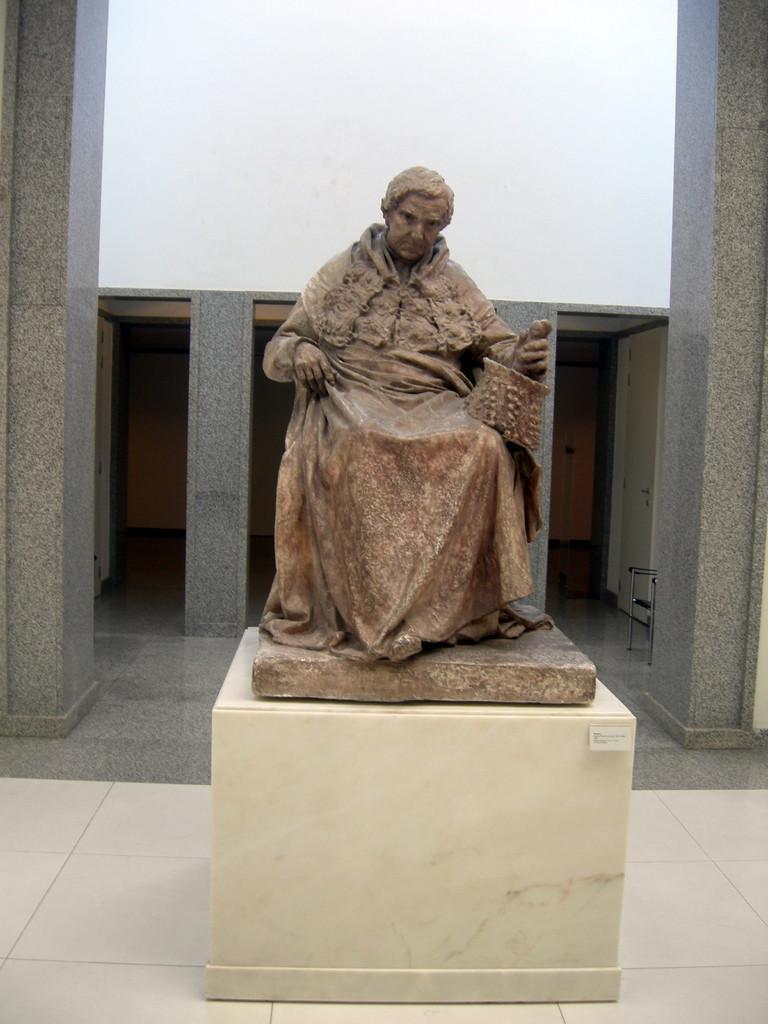In one or two sentences, can you explain what this image depicts? In the image we can see the sculpture of a person sitting wearing clothes and holding an object in hand. Here we can see doors, chair, marble wall and a floor. 